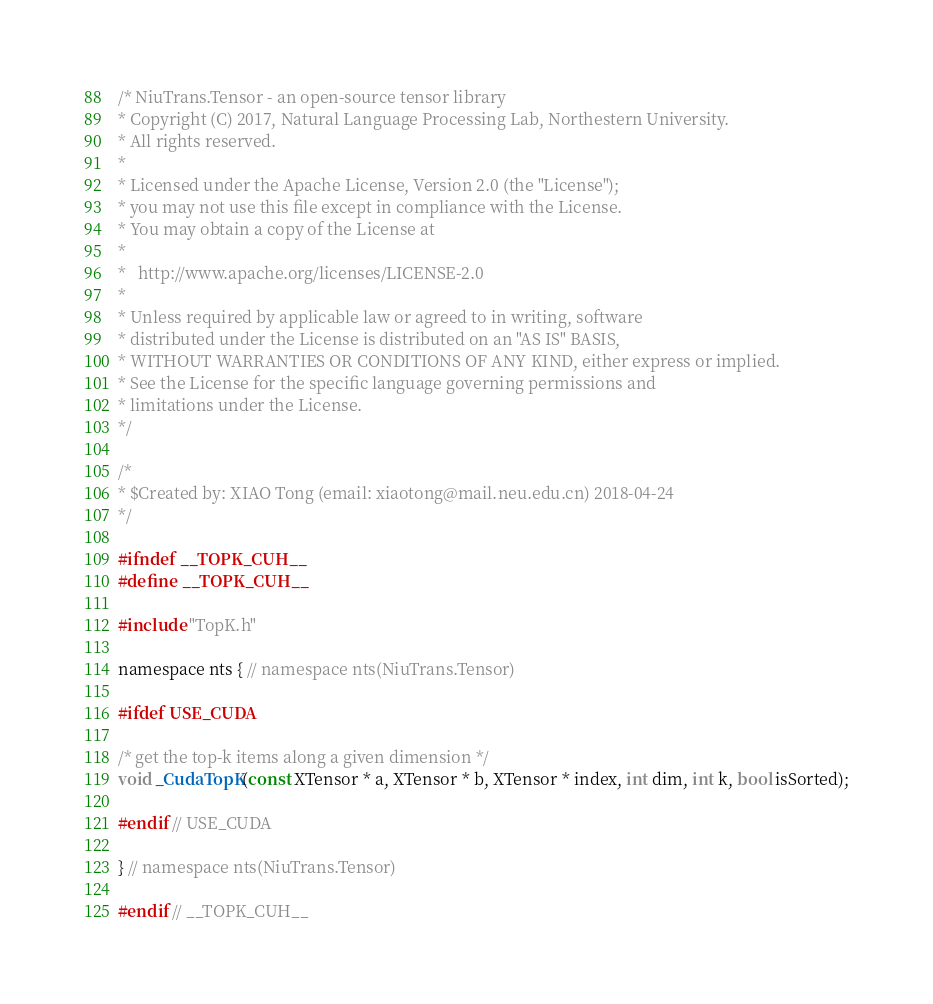Convert code to text. <code><loc_0><loc_0><loc_500><loc_500><_Cuda_>/* NiuTrans.Tensor - an open-source tensor library
* Copyright (C) 2017, Natural Language Processing Lab, Northestern University.
* All rights reserved.
*
* Licensed under the Apache License, Version 2.0 (the "License");
* you may not use this file except in compliance with the License.
* You may obtain a copy of the License at
*
*   http://www.apache.org/licenses/LICENSE-2.0
*
* Unless required by applicable law or agreed to in writing, software
* distributed under the License is distributed on an "AS IS" BASIS,
* WITHOUT WARRANTIES OR CONDITIONS OF ANY KIND, either express or implied.
* See the License for the specific language governing permissions and
* limitations under the License.
*/

/*
* $Created by: XIAO Tong (email: xiaotong@mail.neu.edu.cn) 2018-04-24
*/

#ifndef __TOPK_CUH__
#define __TOPK_CUH__

#include "TopK.h"

namespace nts { // namespace nts(NiuTrans.Tensor)

#ifdef USE_CUDA

/* get the top-k items along a given dimension */
void _CudaTopK(const XTensor * a, XTensor * b, XTensor * index, int dim, int k, bool isSorted);

#endif // USE_CUDA

} // namespace nts(NiuTrans.Tensor)

#endif // __TOPK_CUH__</code> 